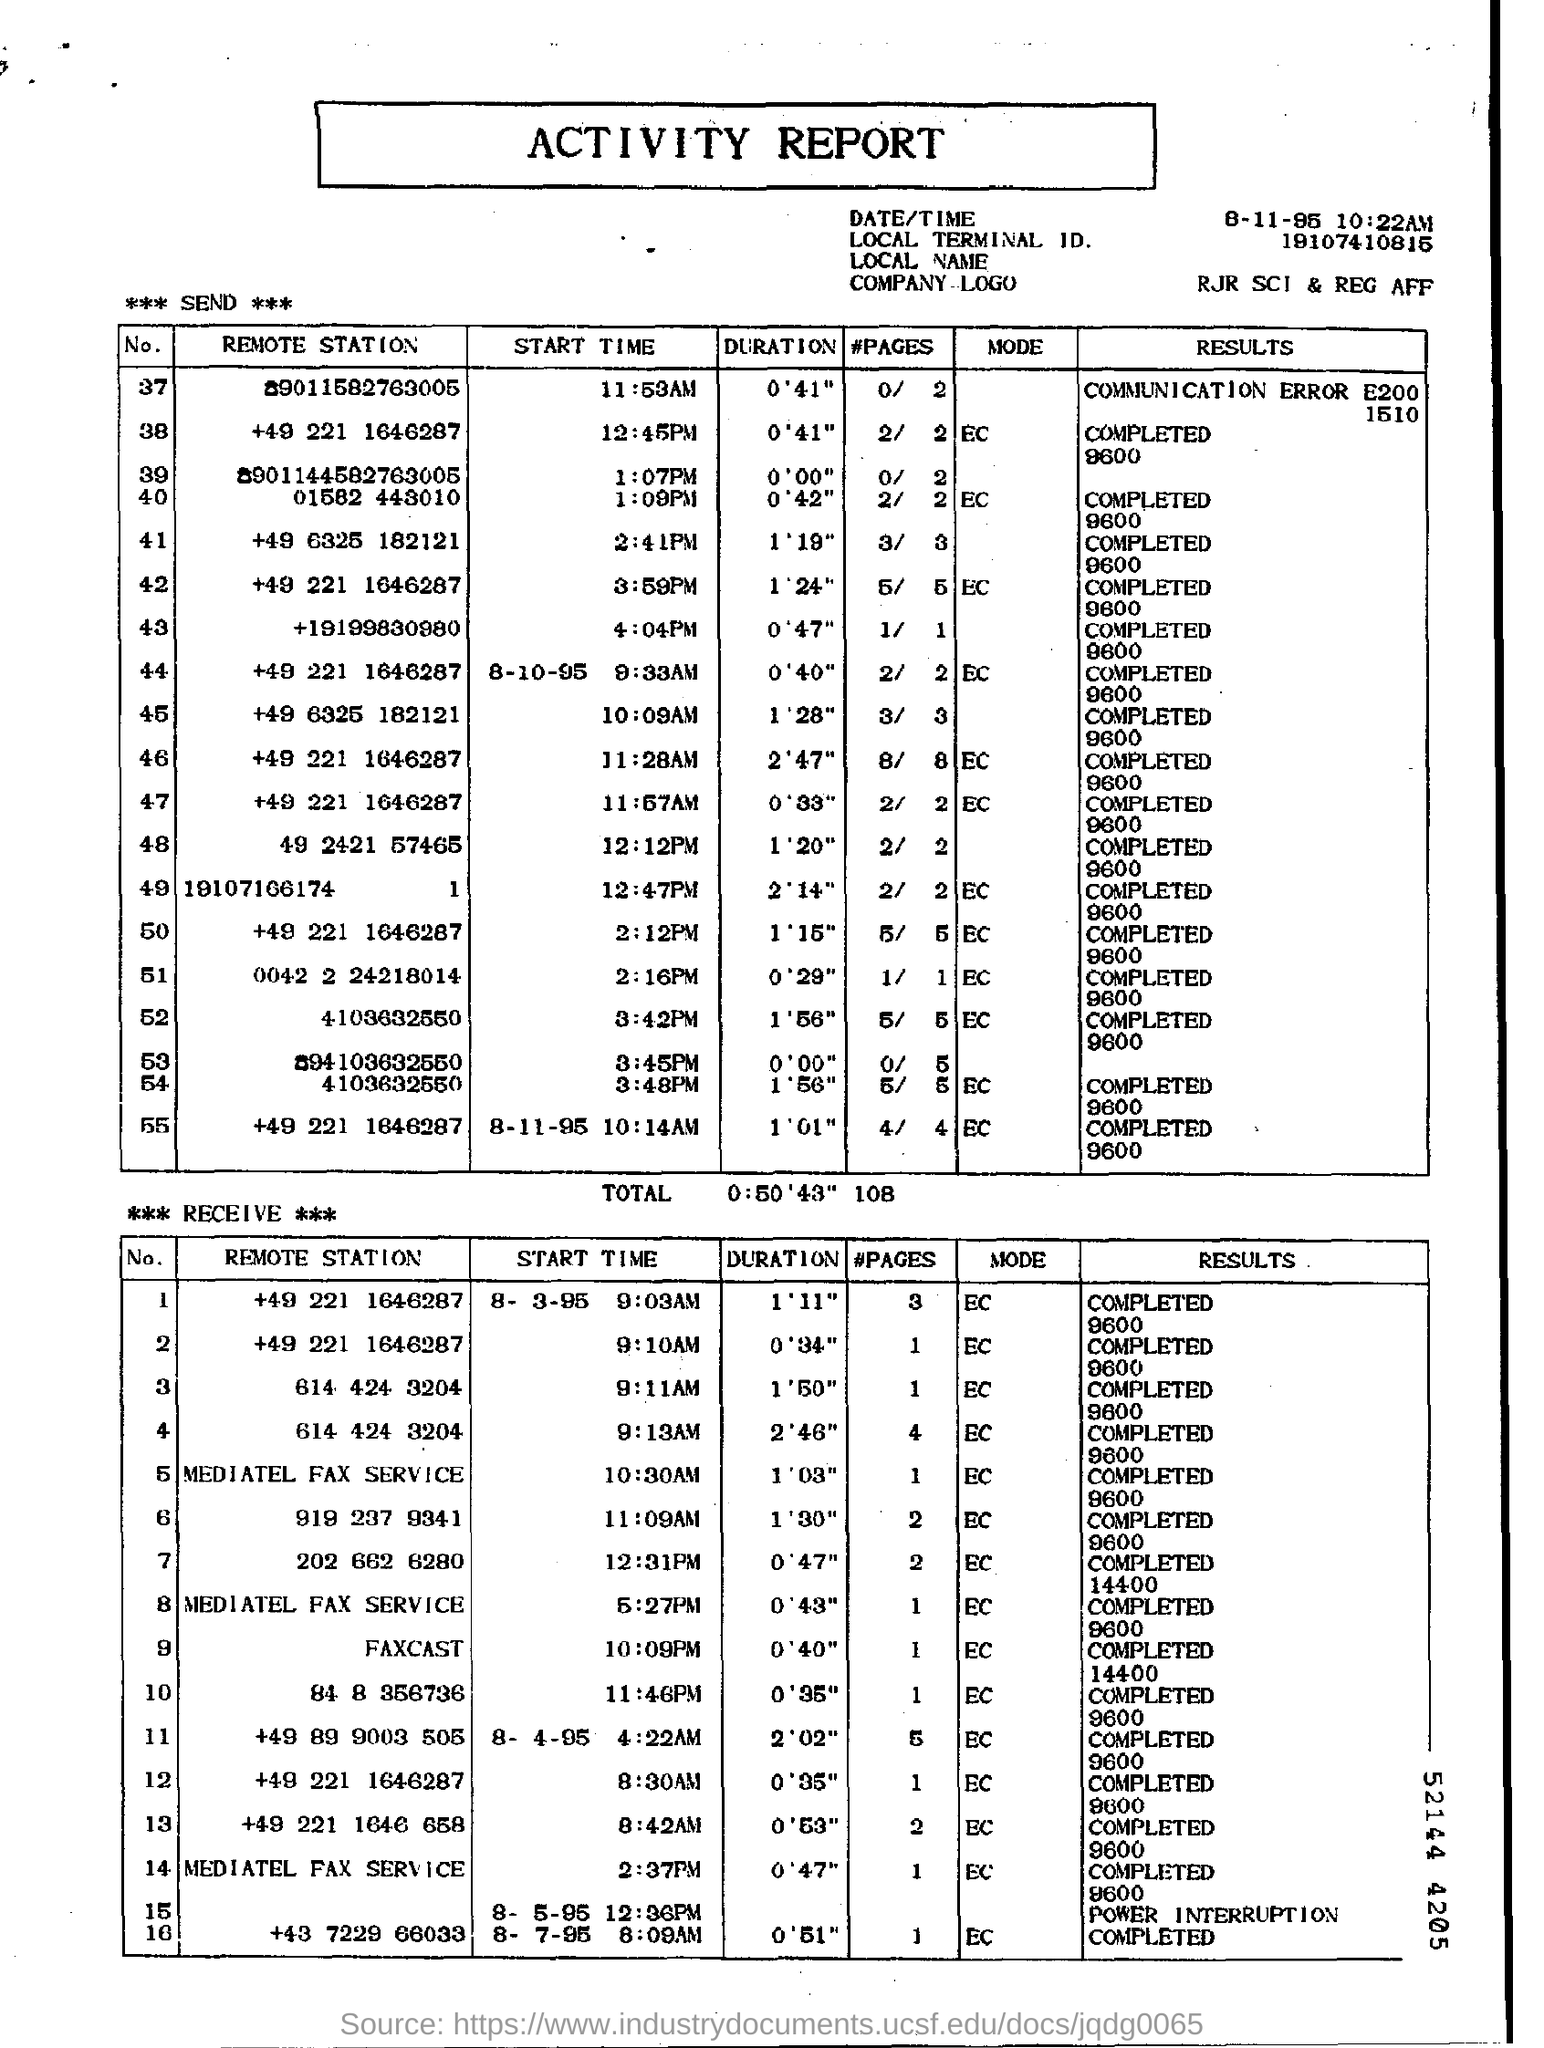Find out the start time item no: 37?
Keep it short and to the point. 11.53AM. 